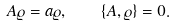<formula> <loc_0><loc_0><loc_500><loc_500>A \varrho = a \varrho , \quad \left \{ A , \varrho \right \} = 0 .</formula> 